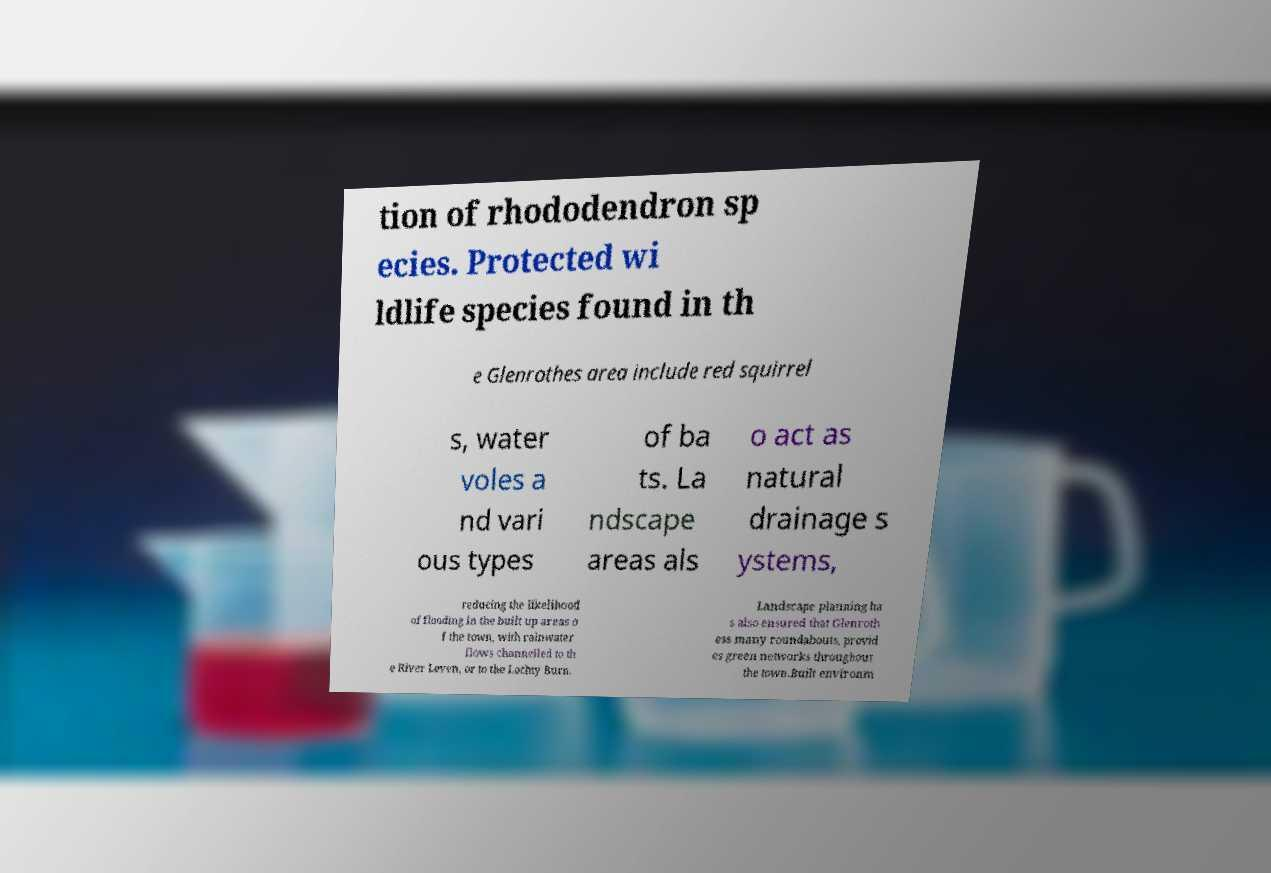For documentation purposes, I need the text within this image transcribed. Could you provide that? tion of rhododendron sp ecies. Protected wi ldlife species found in th e Glenrothes area include red squirrel s, water voles a nd vari ous types of ba ts. La ndscape areas als o act as natural drainage s ystems, reducing the likelihood of flooding in the built up areas o f the town, with rainwater flows channelled to th e River Leven, or to the Lochty Burn. Landscape planning ha s also ensured that Glenroth ess many roundabouts, provid es green networks throughout the town.Built environm 